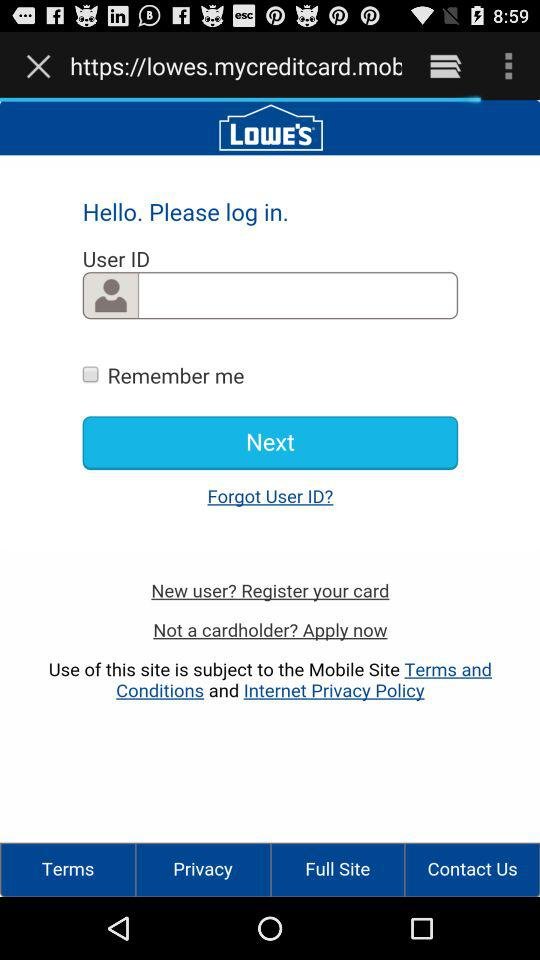What is the application name? The application name is "Lowe's". 